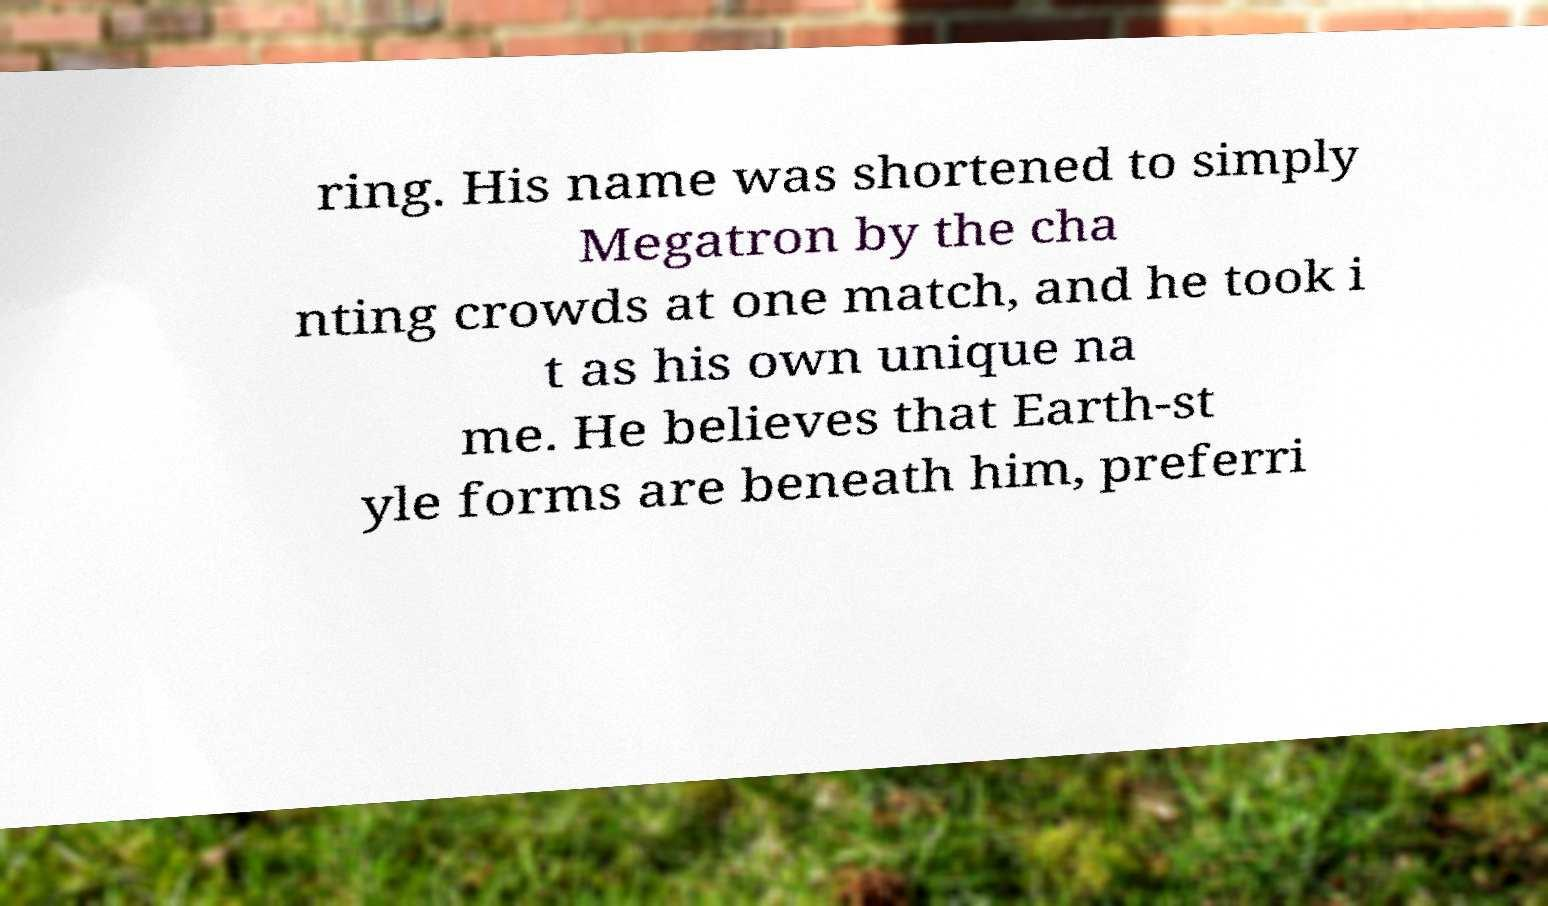Please identify and transcribe the text found in this image. ring. His name was shortened to simply Megatron by the cha nting crowds at one match, and he took i t as his own unique na me. He believes that Earth-st yle forms are beneath him, preferri 